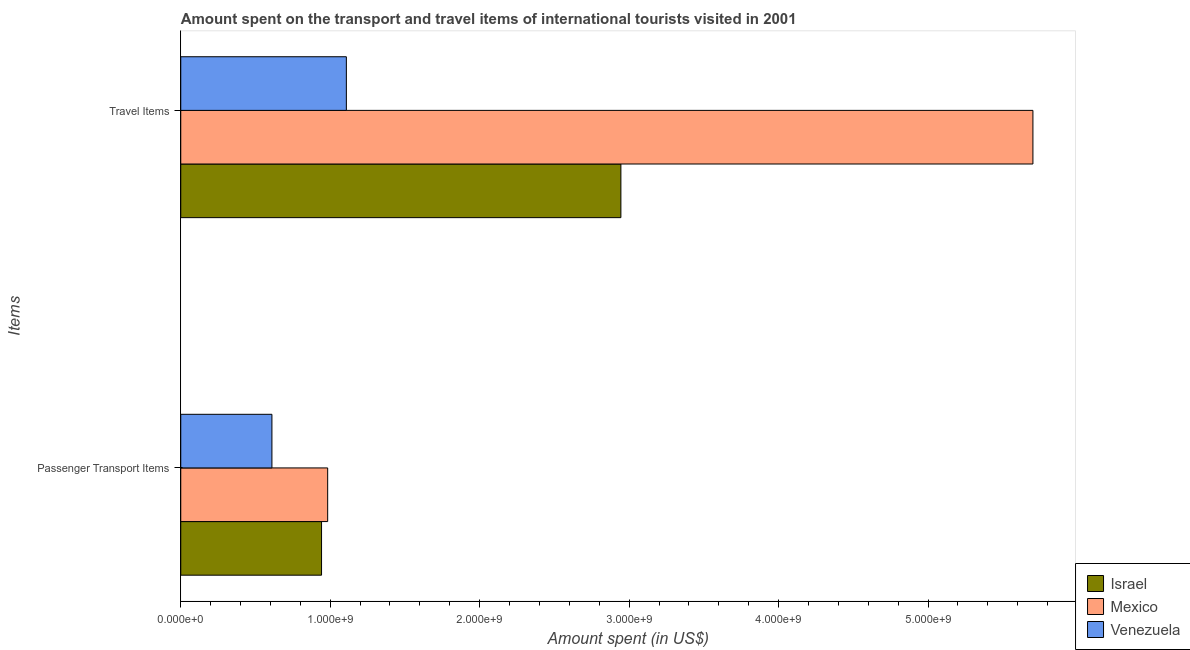How many different coloured bars are there?
Your answer should be very brief. 3. Are the number of bars on each tick of the Y-axis equal?
Ensure brevity in your answer.  Yes. How many bars are there on the 1st tick from the bottom?
Offer a very short reply. 3. What is the label of the 2nd group of bars from the top?
Provide a short and direct response. Passenger Transport Items. What is the amount spent in travel items in Venezuela?
Keep it short and to the point. 1.11e+09. Across all countries, what is the maximum amount spent on passenger transport items?
Your answer should be very brief. 9.83e+08. Across all countries, what is the minimum amount spent on passenger transport items?
Make the answer very short. 6.10e+08. In which country was the amount spent on passenger transport items minimum?
Ensure brevity in your answer.  Venezuela. What is the total amount spent in travel items in the graph?
Offer a terse response. 9.76e+09. What is the difference between the amount spent in travel items in Venezuela and that in Mexico?
Make the answer very short. -4.59e+09. What is the difference between the amount spent in travel items in Mexico and the amount spent on passenger transport items in Israel?
Offer a terse response. 4.76e+09. What is the average amount spent in travel items per country?
Give a very brief answer. 3.25e+09. What is the difference between the amount spent in travel items and amount spent on passenger transport items in Mexico?
Provide a short and direct response. 4.72e+09. What is the ratio of the amount spent on passenger transport items in Israel to that in Mexico?
Offer a terse response. 0.96. Is the amount spent on passenger transport items in Mexico less than that in Israel?
Provide a succinct answer. No. In how many countries, is the amount spent on passenger transport items greater than the average amount spent on passenger transport items taken over all countries?
Provide a short and direct response. 2. What does the 1st bar from the top in Passenger Transport Items represents?
Your response must be concise. Venezuela. What does the 2nd bar from the bottom in Travel Items represents?
Ensure brevity in your answer.  Mexico. Are all the bars in the graph horizontal?
Your answer should be very brief. Yes. What is the difference between two consecutive major ticks on the X-axis?
Your answer should be compact. 1.00e+09. Does the graph contain any zero values?
Your answer should be very brief. No. Does the graph contain grids?
Offer a very short reply. No. What is the title of the graph?
Your answer should be very brief. Amount spent on the transport and travel items of international tourists visited in 2001. Does "Latvia" appear as one of the legend labels in the graph?
Offer a terse response. No. What is the label or title of the X-axis?
Provide a succinct answer. Amount spent (in US$). What is the label or title of the Y-axis?
Offer a terse response. Items. What is the Amount spent (in US$) in Israel in Passenger Transport Items?
Your answer should be compact. 9.42e+08. What is the Amount spent (in US$) of Mexico in Passenger Transport Items?
Ensure brevity in your answer.  9.83e+08. What is the Amount spent (in US$) of Venezuela in Passenger Transport Items?
Provide a succinct answer. 6.10e+08. What is the Amount spent (in US$) in Israel in Travel Items?
Your response must be concise. 2.94e+09. What is the Amount spent (in US$) of Mexico in Travel Items?
Your response must be concise. 5.70e+09. What is the Amount spent (in US$) of Venezuela in Travel Items?
Your response must be concise. 1.11e+09. Across all Items, what is the maximum Amount spent (in US$) in Israel?
Make the answer very short. 2.94e+09. Across all Items, what is the maximum Amount spent (in US$) of Mexico?
Offer a terse response. 5.70e+09. Across all Items, what is the maximum Amount spent (in US$) of Venezuela?
Provide a succinct answer. 1.11e+09. Across all Items, what is the minimum Amount spent (in US$) in Israel?
Provide a short and direct response. 9.42e+08. Across all Items, what is the minimum Amount spent (in US$) in Mexico?
Your answer should be compact. 9.83e+08. Across all Items, what is the minimum Amount spent (in US$) in Venezuela?
Offer a very short reply. 6.10e+08. What is the total Amount spent (in US$) of Israel in the graph?
Ensure brevity in your answer.  3.89e+09. What is the total Amount spent (in US$) in Mexico in the graph?
Ensure brevity in your answer.  6.68e+09. What is the total Amount spent (in US$) in Venezuela in the graph?
Offer a terse response. 1.72e+09. What is the difference between the Amount spent (in US$) in Israel in Passenger Transport Items and that in Travel Items?
Provide a short and direct response. -2.00e+09. What is the difference between the Amount spent (in US$) in Mexico in Passenger Transport Items and that in Travel Items?
Offer a very short reply. -4.72e+09. What is the difference between the Amount spent (in US$) of Venezuela in Passenger Transport Items and that in Travel Items?
Your answer should be compact. -4.98e+08. What is the difference between the Amount spent (in US$) in Israel in Passenger Transport Items and the Amount spent (in US$) in Mexico in Travel Items?
Give a very brief answer. -4.76e+09. What is the difference between the Amount spent (in US$) in Israel in Passenger Transport Items and the Amount spent (in US$) in Venezuela in Travel Items?
Your answer should be compact. -1.66e+08. What is the difference between the Amount spent (in US$) in Mexico in Passenger Transport Items and the Amount spent (in US$) in Venezuela in Travel Items?
Ensure brevity in your answer.  -1.25e+08. What is the average Amount spent (in US$) in Israel per Items?
Provide a short and direct response. 1.94e+09. What is the average Amount spent (in US$) in Mexico per Items?
Ensure brevity in your answer.  3.34e+09. What is the average Amount spent (in US$) in Venezuela per Items?
Offer a very short reply. 8.59e+08. What is the difference between the Amount spent (in US$) in Israel and Amount spent (in US$) in Mexico in Passenger Transport Items?
Provide a succinct answer. -4.10e+07. What is the difference between the Amount spent (in US$) in Israel and Amount spent (in US$) in Venezuela in Passenger Transport Items?
Provide a succinct answer. 3.32e+08. What is the difference between the Amount spent (in US$) in Mexico and Amount spent (in US$) in Venezuela in Passenger Transport Items?
Offer a very short reply. 3.73e+08. What is the difference between the Amount spent (in US$) of Israel and Amount spent (in US$) of Mexico in Travel Items?
Your response must be concise. -2.76e+09. What is the difference between the Amount spent (in US$) in Israel and Amount spent (in US$) in Venezuela in Travel Items?
Your answer should be very brief. 1.84e+09. What is the difference between the Amount spent (in US$) of Mexico and Amount spent (in US$) of Venezuela in Travel Items?
Your answer should be very brief. 4.59e+09. What is the ratio of the Amount spent (in US$) in Israel in Passenger Transport Items to that in Travel Items?
Keep it short and to the point. 0.32. What is the ratio of the Amount spent (in US$) of Mexico in Passenger Transport Items to that in Travel Items?
Your response must be concise. 0.17. What is the ratio of the Amount spent (in US$) of Venezuela in Passenger Transport Items to that in Travel Items?
Provide a short and direct response. 0.55. What is the difference between the highest and the second highest Amount spent (in US$) of Israel?
Give a very brief answer. 2.00e+09. What is the difference between the highest and the second highest Amount spent (in US$) of Mexico?
Give a very brief answer. 4.72e+09. What is the difference between the highest and the second highest Amount spent (in US$) of Venezuela?
Offer a terse response. 4.98e+08. What is the difference between the highest and the lowest Amount spent (in US$) in Israel?
Your answer should be very brief. 2.00e+09. What is the difference between the highest and the lowest Amount spent (in US$) of Mexico?
Give a very brief answer. 4.72e+09. What is the difference between the highest and the lowest Amount spent (in US$) in Venezuela?
Give a very brief answer. 4.98e+08. 